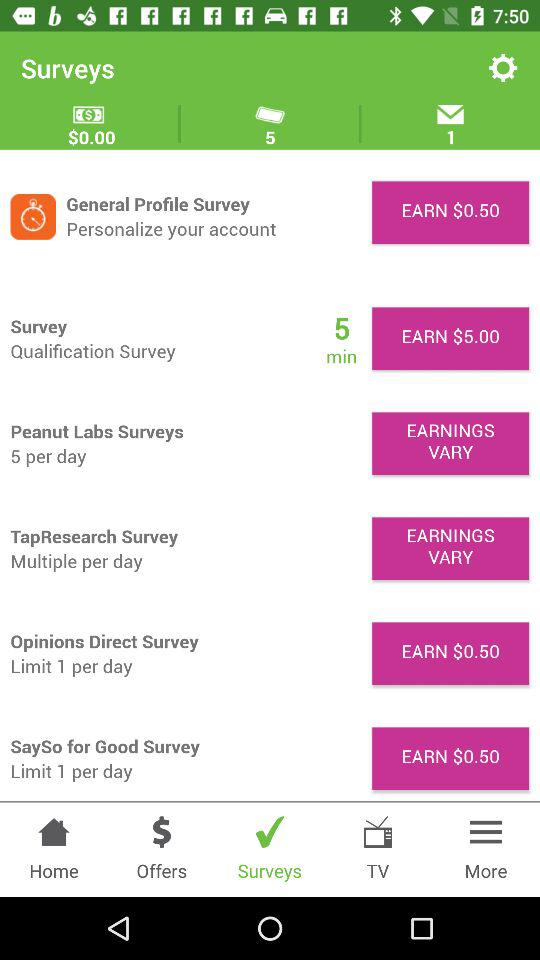What is the earning amount for the survey? The earning amount for the survey is $5.00. 